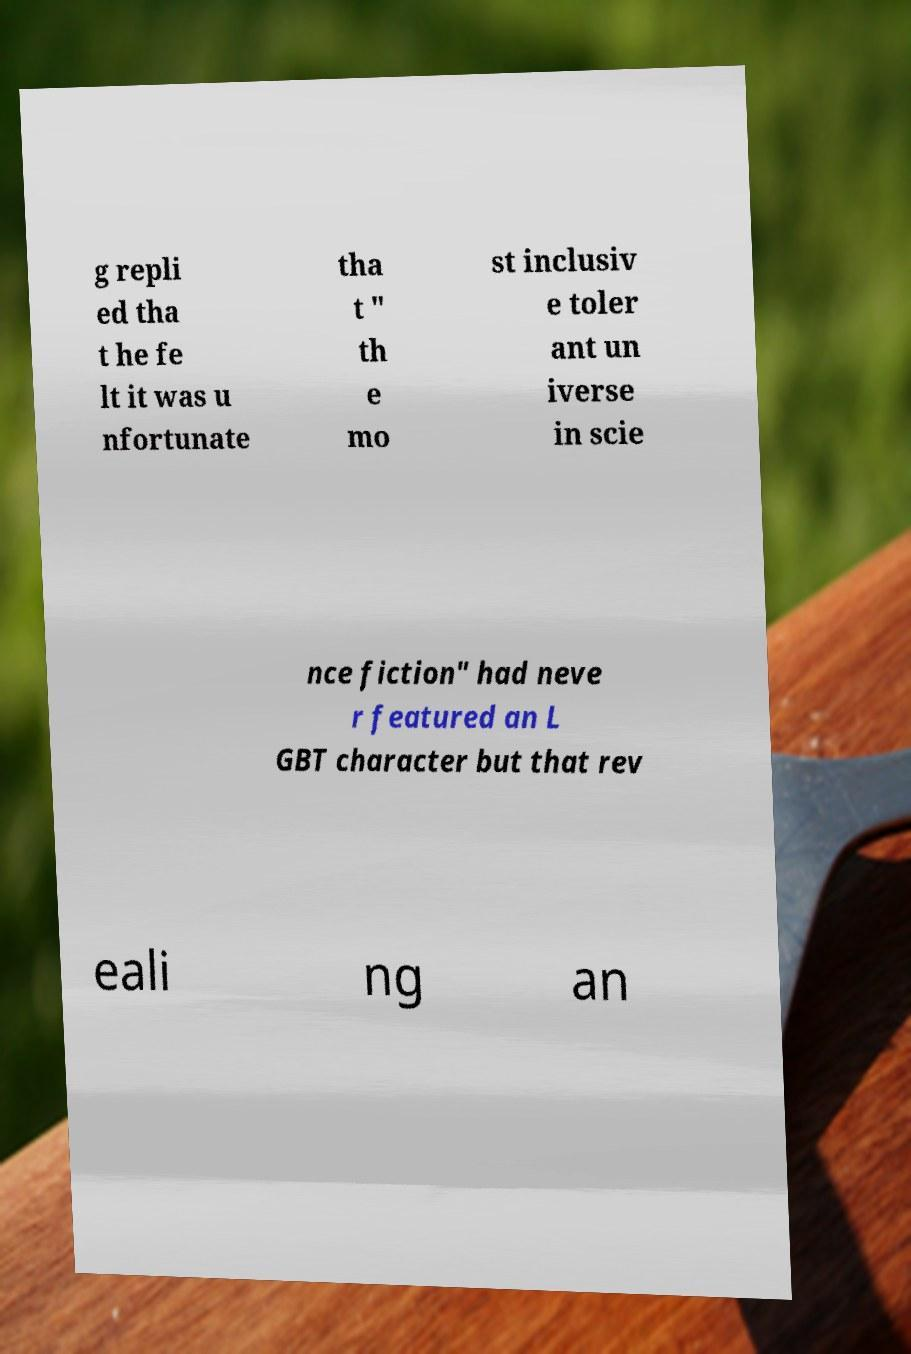Can you accurately transcribe the text from the provided image for me? g repli ed tha t he fe lt it was u nfortunate tha t " th e mo st inclusiv e toler ant un iverse in scie nce fiction" had neve r featured an L GBT character but that rev eali ng an 